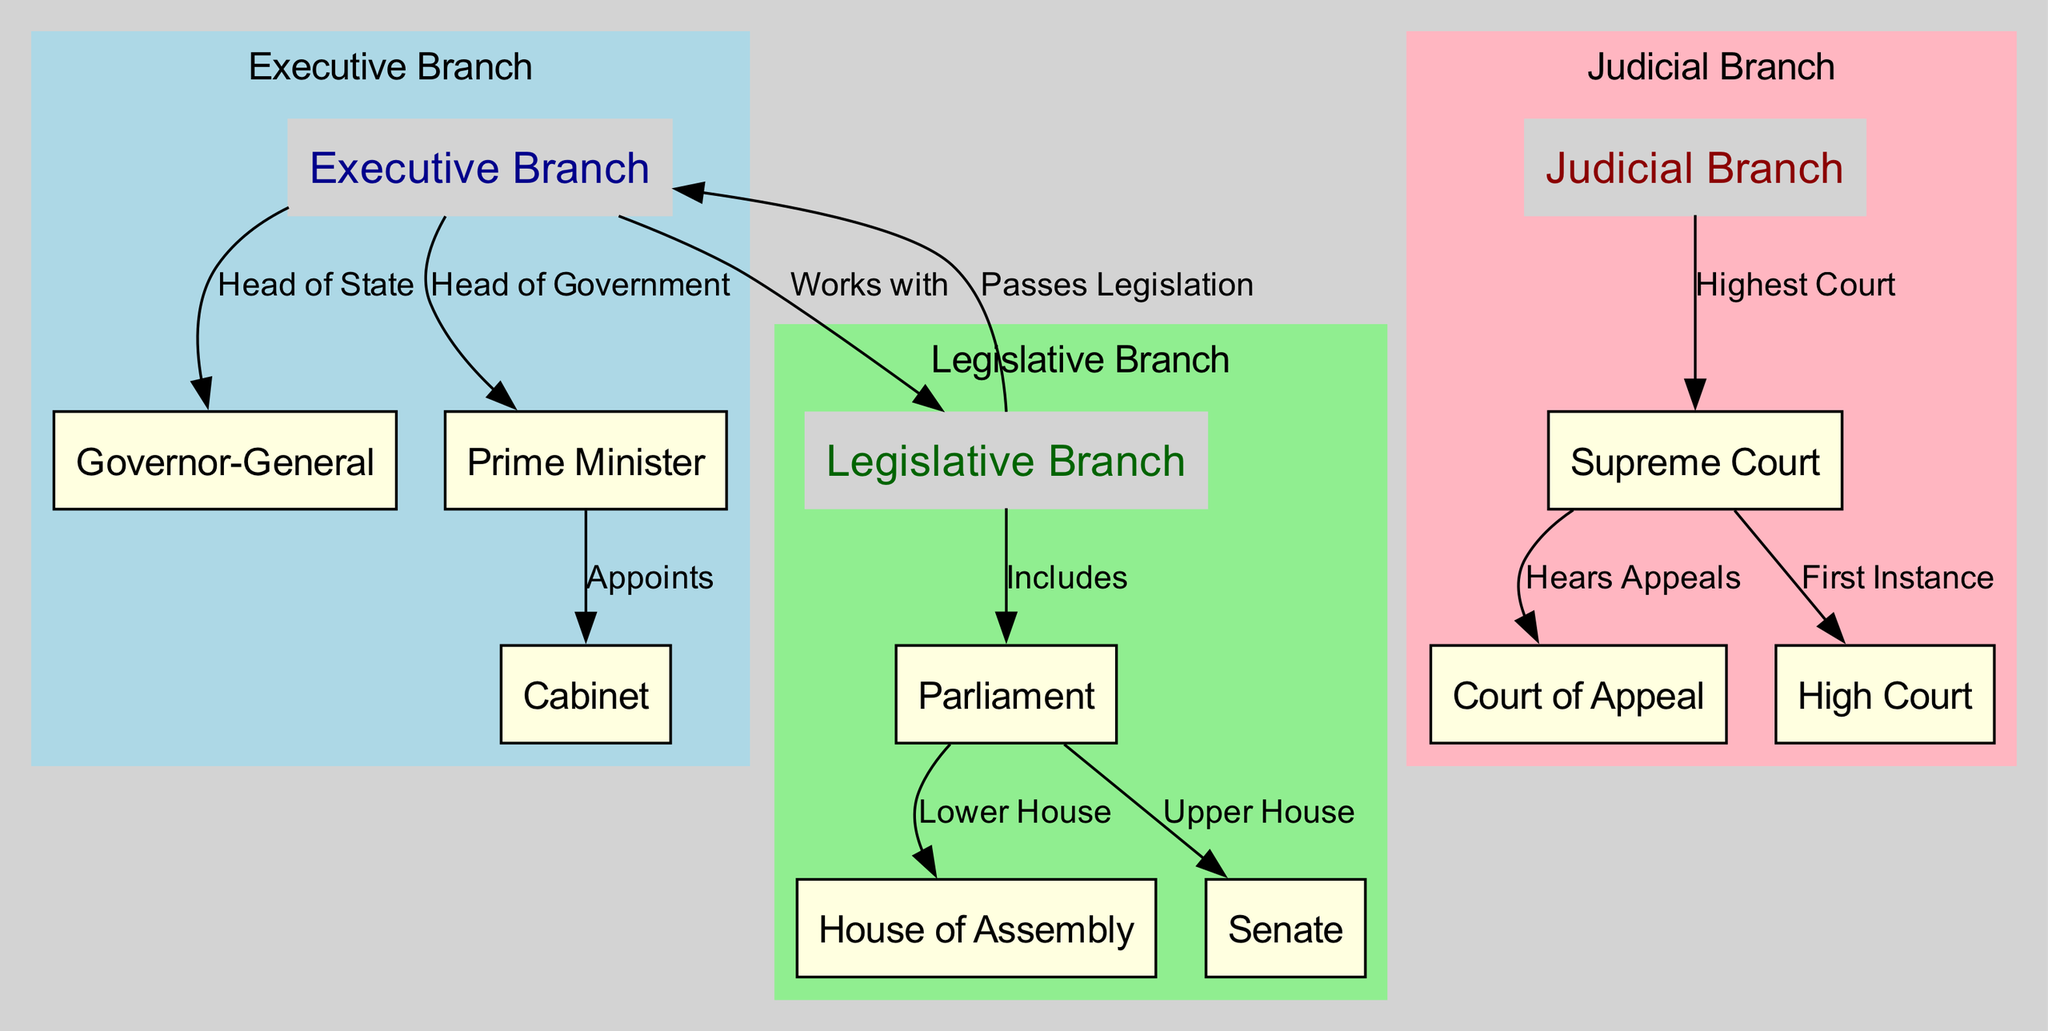What is the highest court in Barbados? According to the diagram, the Supreme Court is indicated as the highest court under the judicial branch.
Answer: Supreme Court Who heads the executive branch? The diagram shows that the Governor-General is labeled as the Head of State within the executive branch.
Answer: Governor-General How many branches of government are depicted in the diagram? The diagram clearly shows three branches of government: executive, legislative, and judicial.
Answer: Three What role does the Prime Minister have in relation to the Cabinet? The diagram indicates that the Prime Minister appoints the Cabinet, establishing a direct relationship between these two nodes.
Answer: Appoints Which house is designated as the upper house in the legislative branch? The diagram specifies the Senate as the upper house within the legislative branch, distinguishing it from the House of Assembly.
Answer: Senate How does the legislative branch interact with the executive branch? The diagram indicates that the legislative branch passes legislation that affects the executive branch, establishing a reciprocal relationship.
Answer: Passes Legislation Which court hears appeals from the Supreme Court? The diagram illustrates that the Court of Appeal hears appeals stemming from decisions made in the Supreme Court.
Answer: Court of Appeal What is the function of the Cabinet in the executive branch? The diagram does not explicitly state the function but shows the Cabinet as a component that is appointed by the Prime Minister, indicating its role in governance.
Answer: Part of governance What relationship does the executive branch have with the legislative branch? The diagram reveals that the executive branch works with the legislative branch to carry out governance and law-making processes.
Answer: Works with 